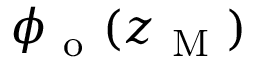<formula> <loc_0><loc_0><loc_500><loc_500>\phi _ { o } ( z _ { M } )</formula> 